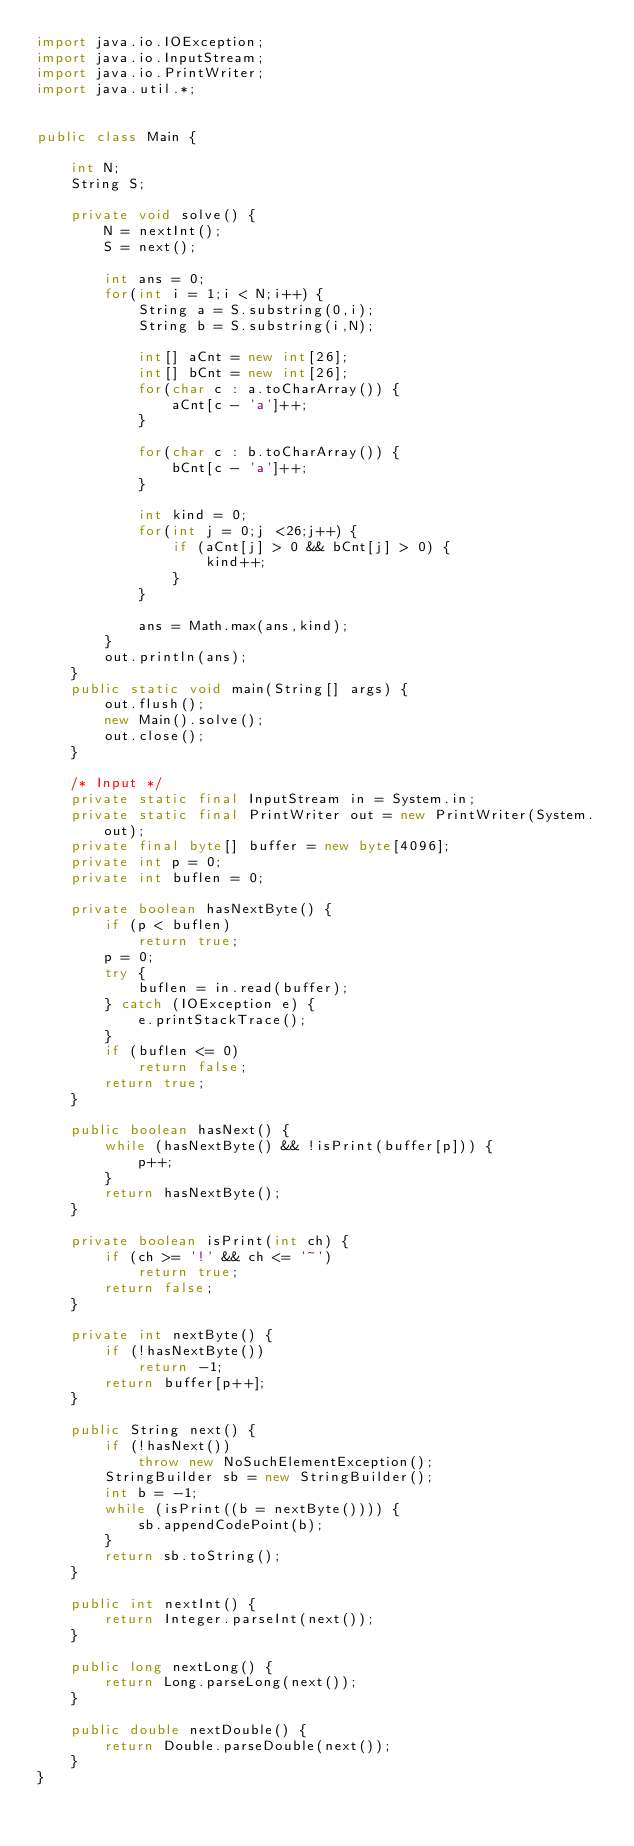Convert code to text. <code><loc_0><loc_0><loc_500><loc_500><_Java_>import java.io.IOException;
import java.io.InputStream;
import java.io.PrintWriter;
import java.util.*;


public class Main {

    int N;
    String S;

    private void solve() {
        N = nextInt();
        S = next();

        int ans = 0;
        for(int i = 1;i < N;i++) {
            String a = S.substring(0,i);
            String b = S.substring(i,N);

            int[] aCnt = new int[26];
            int[] bCnt = new int[26];
            for(char c : a.toCharArray()) {
                aCnt[c - 'a']++;
            }

            for(char c : b.toCharArray()) {
                bCnt[c - 'a']++;
            }

            int kind = 0;
            for(int j = 0;j <26;j++) {
                if (aCnt[j] > 0 && bCnt[j] > 0) {
                    kind++;
                }
            }

            ans = Math.max(ans,kind);
        }
        out.println(ans);
    }
    public static void main(String[] args) {
        out.flush();
        new Main().solve();
        out.close();
    }

    /* Input */
    private static final InputStream in = System.in;
    private static final PrintWriter out = new PrintWriter(System.out);
    private final byte[] buffer = new byte[4096];
    private int p = 0;
    private int buflen = 0;

    private boolean hasNextByte() {
        if (p < buflen)
            return true;
        p = 0;
        try {
            buflen = in.read(buffer);
        } catch (IOException e) {
            e.printStackTrace();
        }
        if (buflen <= 0)
            return false;
        return true;
    }

    public boolean hasNext() {
        while (hasNextByte() && !isPrint(buffer[p])) {
            p++;
        }
        return hasNextByte();
    }

    private boolean isPrint(int ch) {
        if (ch >= '!' && ch <= '~')
            return true;
        return false;
    }

    private int nextByte() {
        if (!hasNextByte())
            return -1;
        return buffer[p++];
    }

    public String next() {
        if (!hasNext())
            throw new NoSuchElementException();
        StringBuilder sb = new StringBuilder();
        int b = -1;
        while (isPrint((b = nextByte()))) {
            sb.appendCodePoint(b);
        }
        return sb.toString();
    }

    public int nextInt() {
        return Integer.parseInt(next());
    }

    public long nextLong() {
        return Long.parseLong(next());
    }

    public double nextDouble() {
        return Double.parseDouble(next());
    }
}
</code> 